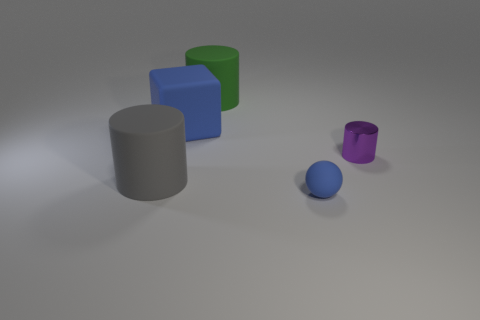Subtract all large gray cylinders. How many cylinders are left? 2 Add 3 metal cylinders. How many objects exist? 8 Subtract all gray cylinders. How many cylinders are left? 2 Subtract all cylinders. How many objects are left? 2 Subtract all blue cubes. How many brown balls are left? 0 Subtract all small purple things. Subtract all small purple shiny cylinders. How many objects are left? 3 Add 3 small rubber objects. How many small rubber objects are left? 4 Add 2 tiny blue cubes. How many tiny blue cubes exist? 2 Subtract 0 gray cubes. How many objects are left? 5 Subtract all gray cylinders. Subtract all yellow cubes. How many cylinders are left? 2 